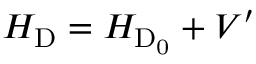<formula> <loc_0><loc_0><loc_500><loc_500>H _ { D } = H _ { D _ { 0 } } + V ^ { \prime }</formula> 